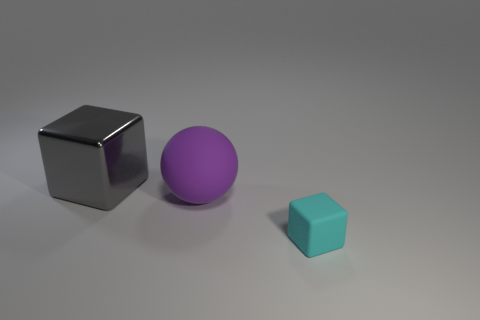Is there any other thing that has the same size as the rubber block?
Provide a succinct answer. No. Is there any other thing that is the same shape as the purple matte object?
Ensure brevity in your answer.  No. There is a small object that is the same shape as the big gray thing; what is its color?
Your answer should be compact. Cyan. There is a block left of the purple rubber ball; is it the same size as the rubber object that is left of the small cyan rubber block?
Ensure brevity in your answer.  Yes. Are there any cyan matte objects that have the same shape as the big gray thing?
Your response must be concise. Yes. Are there the same number of big purple spheres that are in front of the purple ball and large brown spheres?
Your answer should be very brief. Yes. Does the purple matte sphere have the same size as the cube that is to the right of the large cube?
Make the answer very short. No. What number of large things are made of the same material as the small cyan cube?
Your response must be concise. 1. Do the metallic cube and the cyan thing have the same size?
Your response must be concise. No. Is there anything else that is the same color as the small object?
Ensure brevity in your answer.  No. 